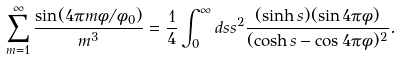Convert formula to latex. <formula><loc_0><loc_0><loc_500><loc_500>\sum _ { m = 1 } ^ { \infty } \frac { \sin ( 4 \pi m \phi / \phi _ { 0 } ) } { m ^ { 3 } } = \frac { 1 } { 4 } \int _ { 0 } ^ { \infty } d s s ^ { 2 } \frac { ( \sinh s ) ( \sin 4 \pi \phi ) } { ( \cosh s - \cos 4 \pi \phi ) ^ { 2 } } .</formula> 